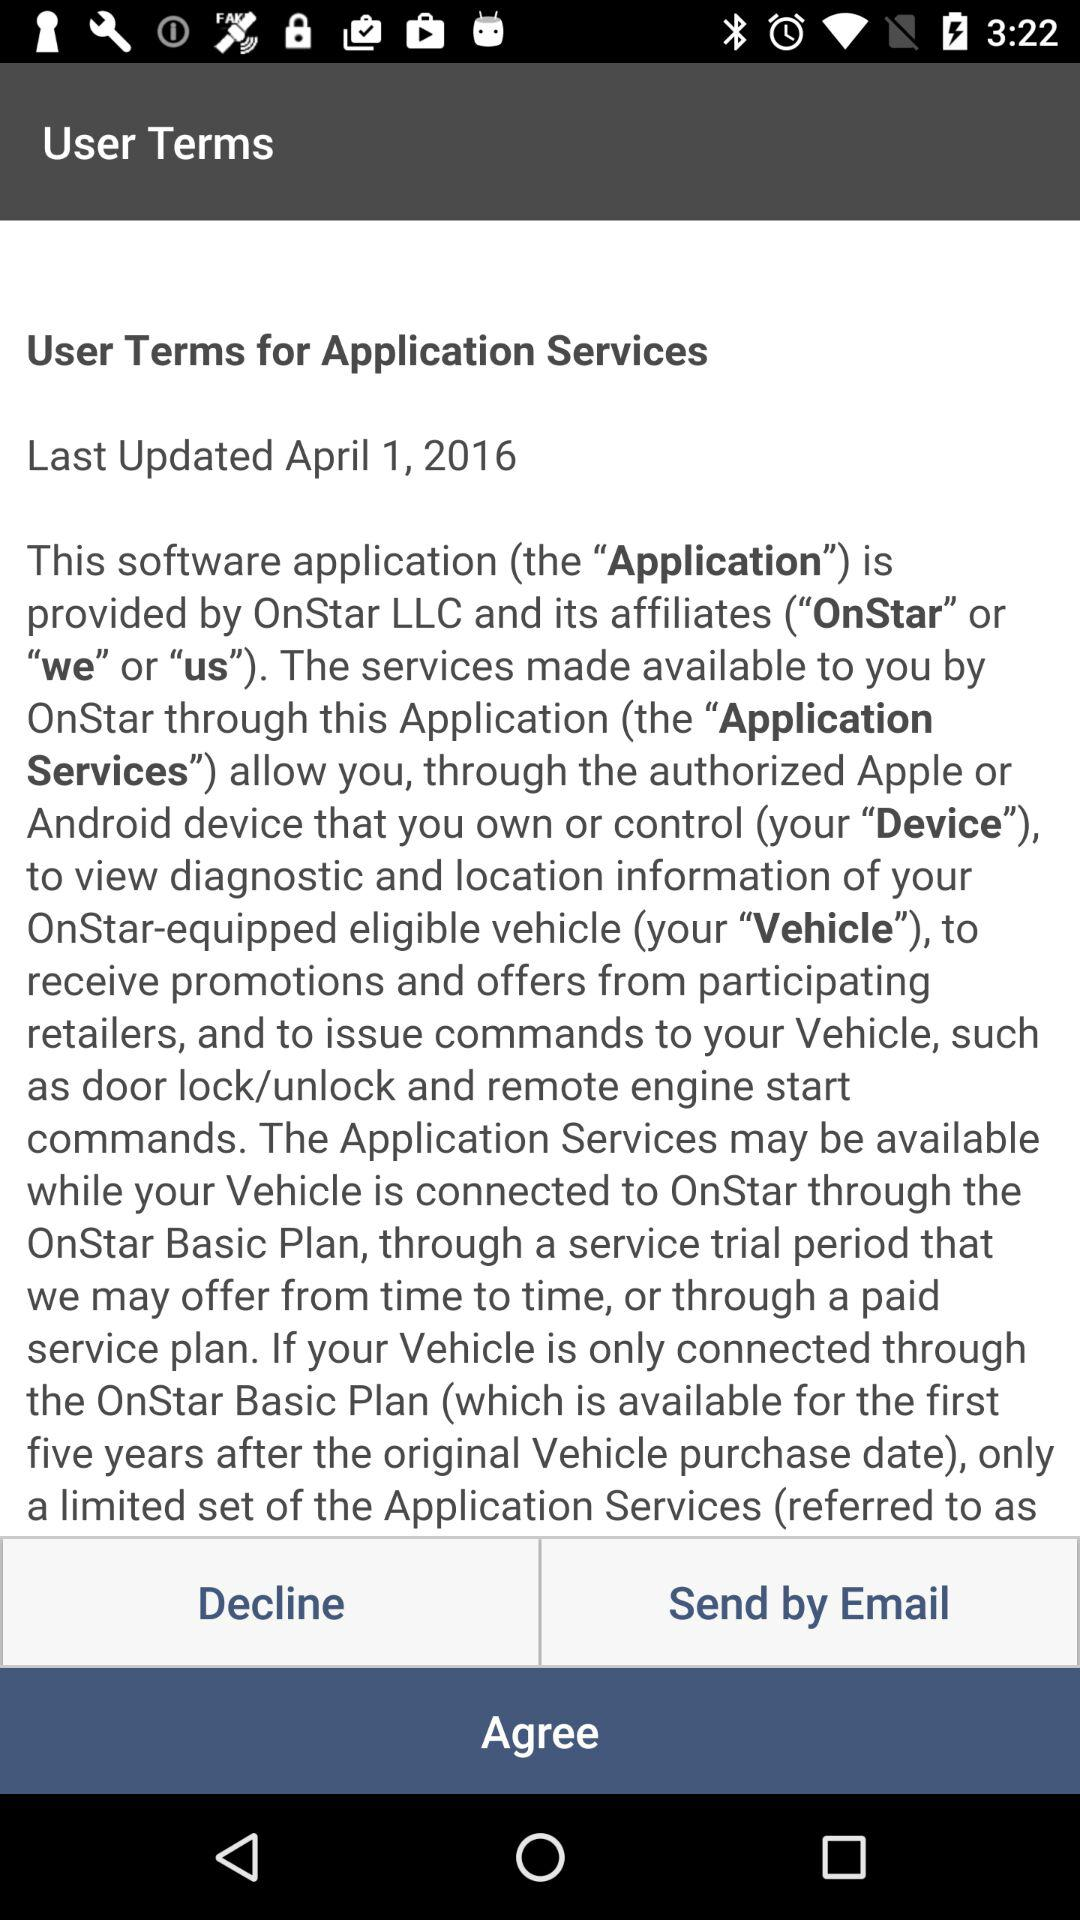When was the "User Terms for Application Services" last updated? The "User Terms for Application Services" was last updated on April 1, 2016. 